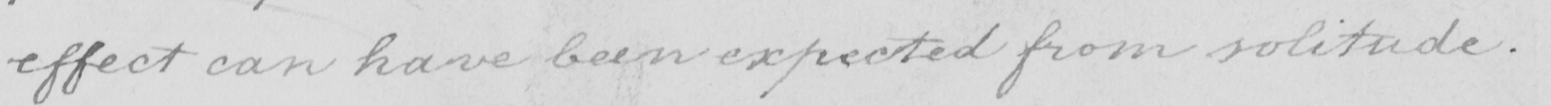Transcribe the text shown in this historical manuscript line. effect can have been expected from solitude . 